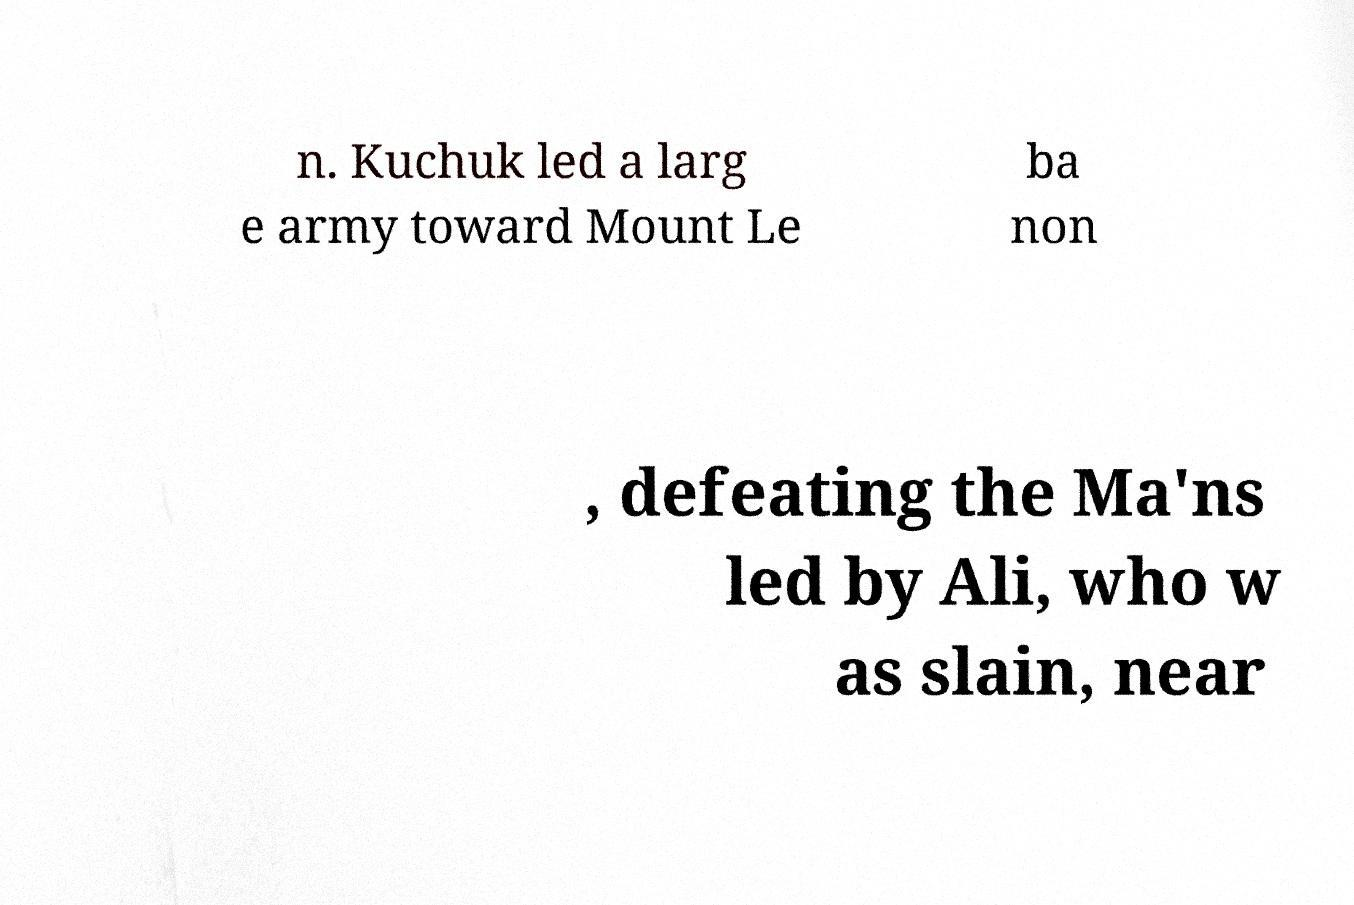Could you extract and type out the text from this image? n. Kuchuk led a larg e army toward Mount Le ba non , defeating the Ma'ns led by Ali, who w as slain, near 